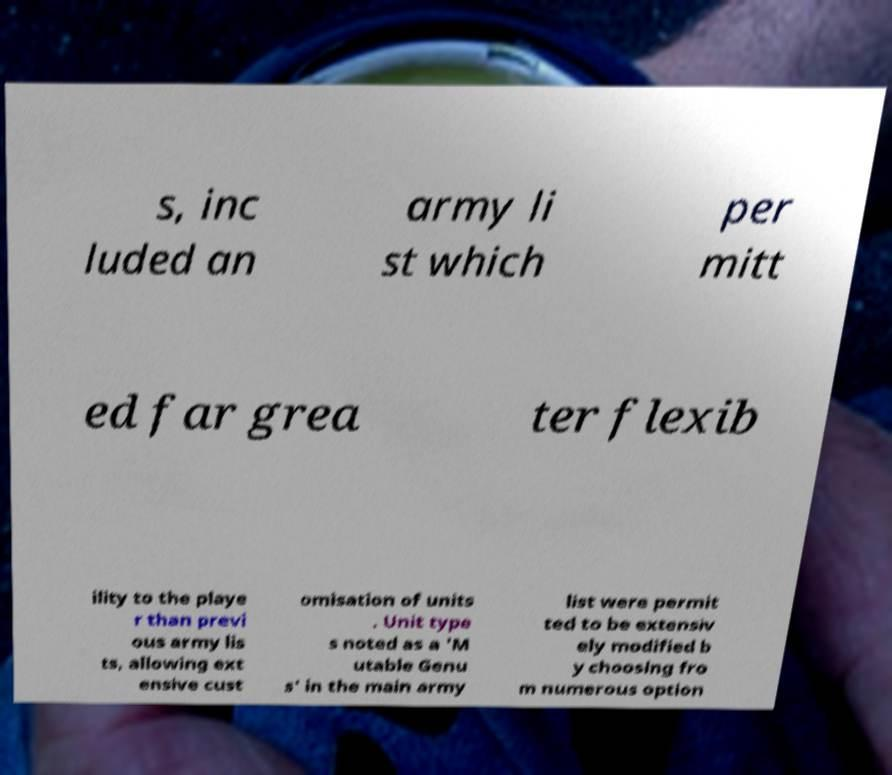I need the written content from this picture converted into text. Can you do that? s, inc luded an army li st which per mitt ed far grea ter flexib ility to the playe r than previ ous army lis ts, allowing ext ensive cust omisation of units . Unit type s noted as a 'M utable Genu s' in the main army list were permit ted to be extensiv ely modified b y choosing fro m numerous option 